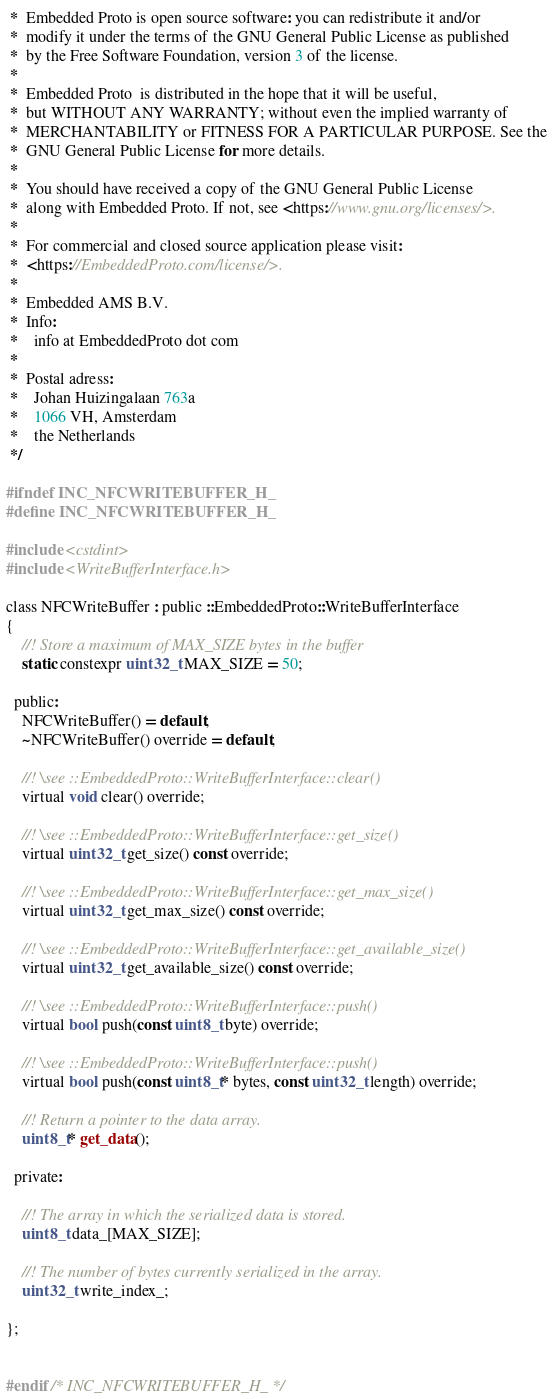<code> <loc_0><loc_0><loc_500><loc_500><_C_> *  Embedded Proto is open source software: you can redistribute it and/or
 *  modify it under the terms of the GNU General Public License as published
 *  by the Free Software Foundation, version 3 of the license.
 *
 *  Embedded Proto  is distributed in the hope that it will be useful,
 *  but WITHOUT ANY WARRANTY; without even the implied warranty of
 *  MERCHANTABILITY or FITNESS FOR A PARTICULAR PURPOSE. See the
 *  GNU General Public License for more details.
 *
 *  You should have received a copy of the GNU General Public License
 *  along with Embedded Proto. If not, see <https://www.gnu.org/licenses/>.
 *
 *  For commercial and closed source application please visit:
 *  <https://EmbeddedProto.com/license/>.
 *
 *  Embedded AMS B.V.
 *  Info:
 *    info at EmbeddedProto dot com
 *
 *  Postal adress:
 *    Johan Huizingalaan 763a
 *    1066 VH, Amsterdam
 *    the Netherlands
 */

#ifndef INC_NFCWRITEBUFFER_H_
#define INC_NFCWRITEBUFFER_H_

#include <cstdint>
#include <WriteBufferInterface.h>

class NFCWriteBuffer : public ::EmbeddedProto::WriteBufferInterface
{
    //! Store a maximum of MAX_SIZE bytes in the buffer
    static constexpr uint32_t MAX_SIZE = 50;

  public:
    NFCWriteBuffer() = default;
    ~NFCWriteBuffer() override = default;

    //! \see ::EmbeddedProto::WriteBufferInterface::clear()
    virtual void clear() override;

    //! \see ::EmbeddedProto::WriteBufferInterface::get_size()
    virtual uint32_t get_size() const override;

    //! \see ::EmbeddedProto::WriteBufferInterface::get_max_size()
    virtual uint32_t get_max_size() const override;

    //! \see ::EmbeddedProto::WriteBufferInterface::get_available_size()
    virtual uint32_t get_available_size() const override;

    //! \see ::EmbeddedProto::WriteBufferInterface::push()
    virtual bool push(const uint8_t byte) override;

    //! \see ::EmbeddedProto::WriteBufferInterface::push()
    virtual bool push(const uint8_t* bytes, const uint32_t length) override;

    //! Return a pointer to the data array.
    uint8_t* get_data();

  private:

    //! The array in which the serialized data is stored.
    uint8_t data_[MAX_SIZE];

    //! The number of bytes currently serialized in the array.
    uint32_t write_index_;

};


#endif /* INC_NFCWRITEBUFFER_H_ */
</code> 